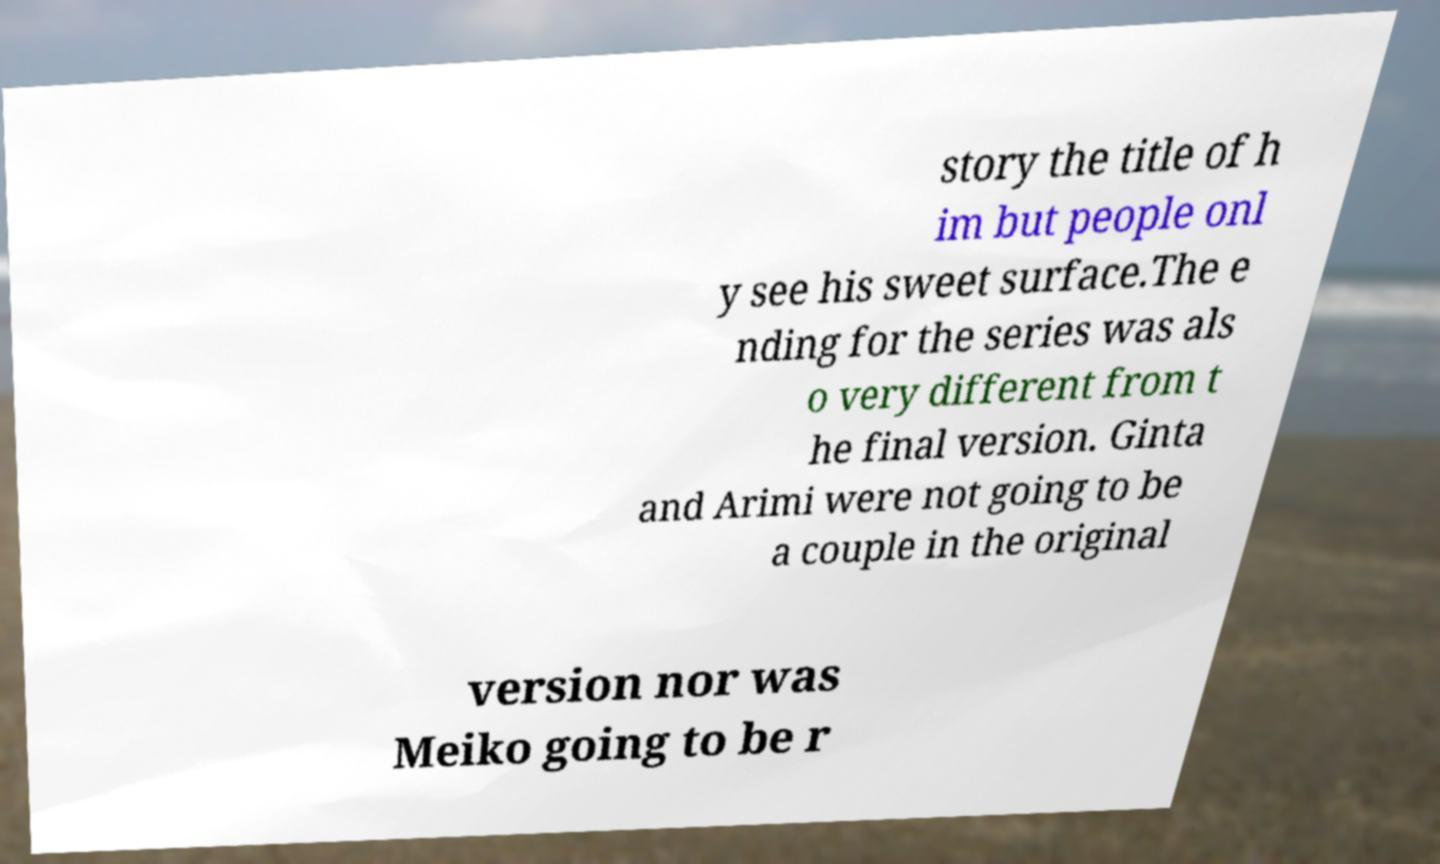What messages or text are displayed in this image? I need them in a readable, typed format. story the title of h im but people onl y see his sweet surface.The e nding for the series was als o very different from t he final version. Ginta and Arimi were not going to be a couple in the original version nor was Meiko going to be r 